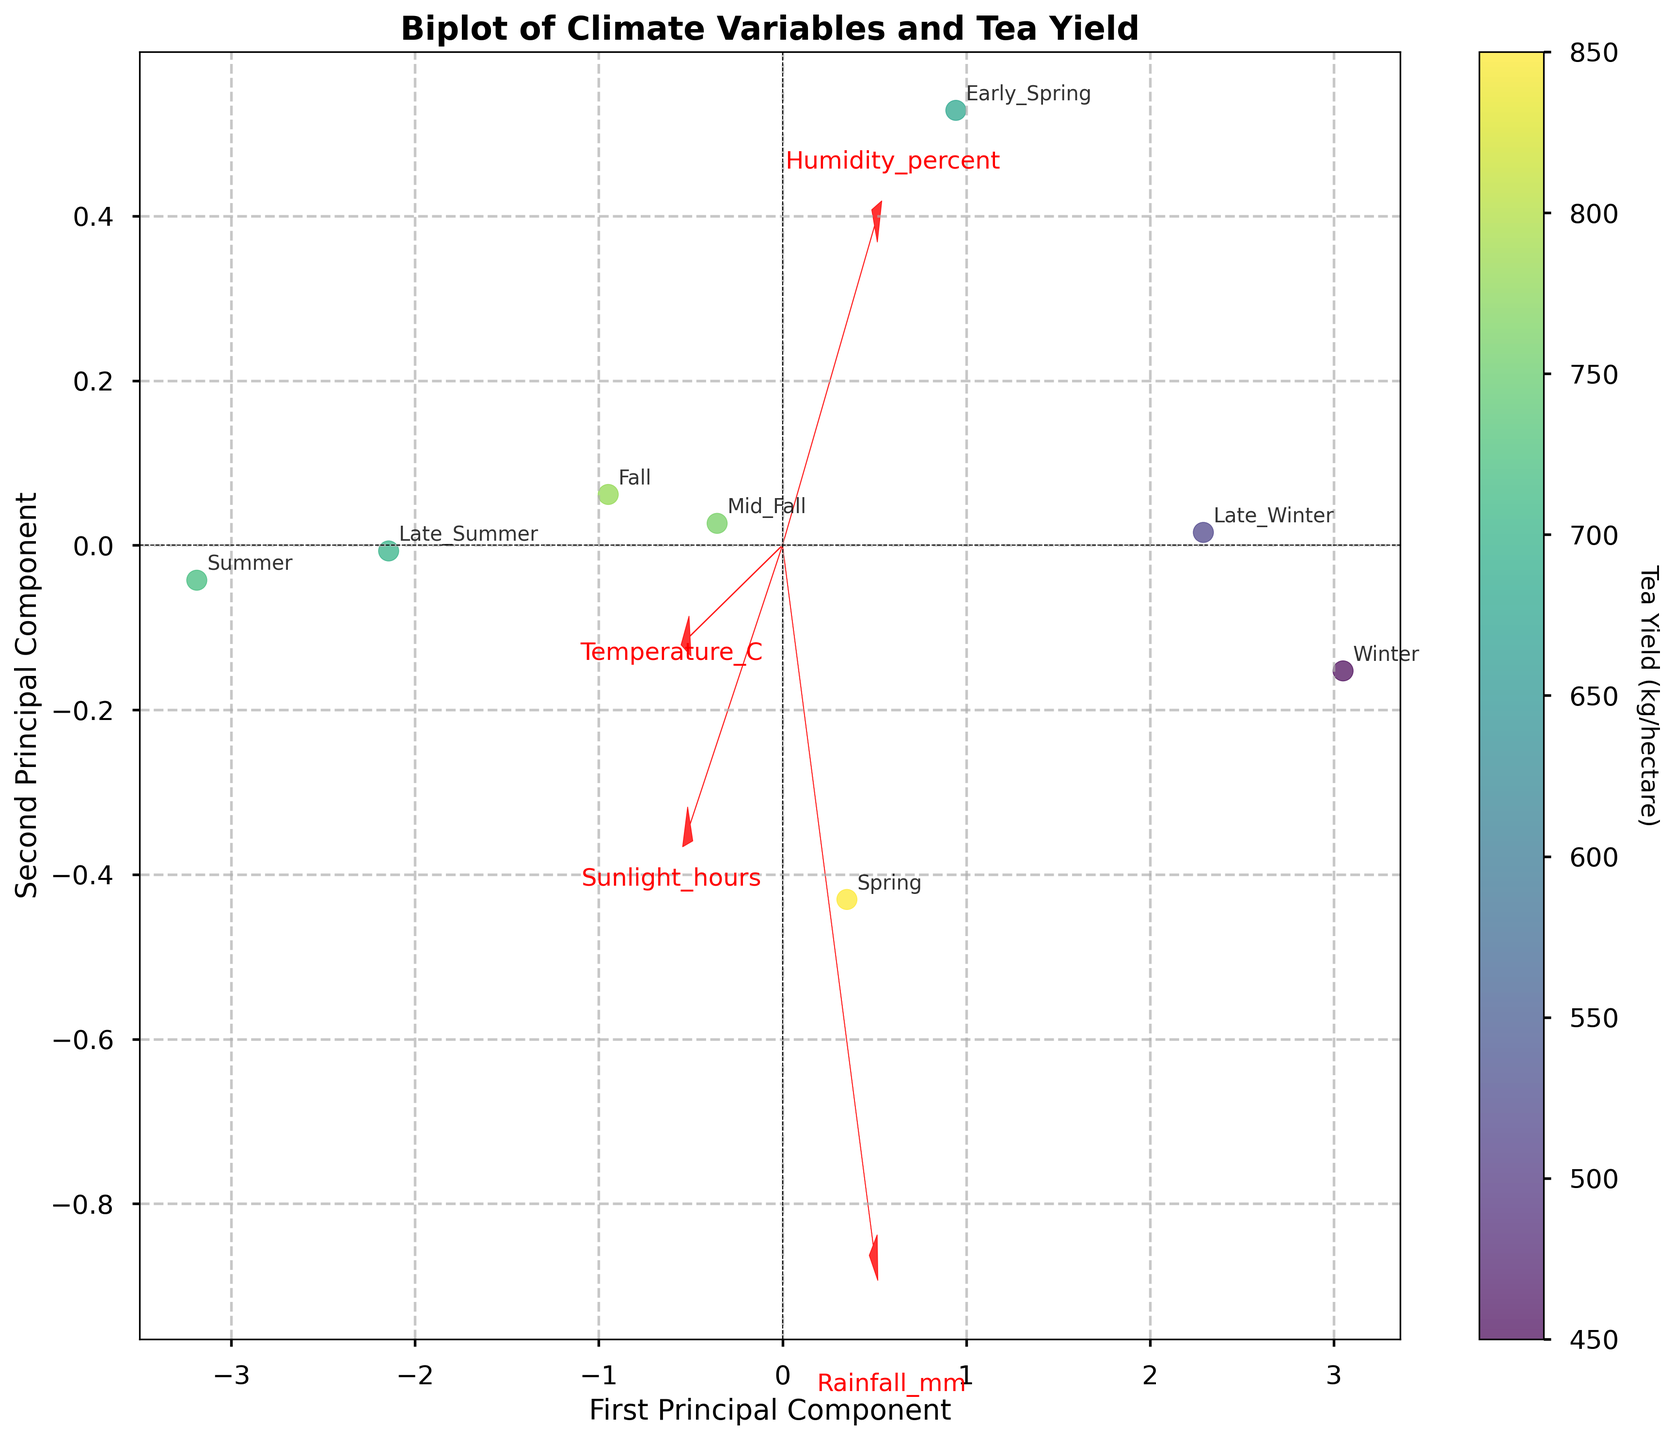What are the labels on the x-axis and y-axis? The labels are "First Principal Component" for the x-axis and "Second Principal Component" for the y-axis. These labels indicate the new coordinates after transforming the original variables using PCA.
Answer: First Principal Component, Second Principal Component Which season is closest to the origin? Look at the x and y coordinates of each labeled season to find which one is nearest to the (0, 0) point on the plot. "Fall" is closest to the origin.
Answer: Fall How does "Spring" relate to "Humidity_percent"? "Spring" is positioned in the direction where the "Humidity_percent" arrow points, indicating a positive relationship. This suggests that higher humidity is associated with Spring.
Answer: Positive relationship What is the color bar representing? The color bar on the right side of the plot is labeled "Tea Yield (kg/hectare)". It shows the tea yield per hectare, with different colors indicating different yields. This helps interpret the influence of climate variables on tea production visually.
Answer: Tea Yield (kg/hectare) Which season has the highest tea yield? By examining the colors of each season's point on the scatter plot, "Spring" is the darkest, indicating it has the highest yield.
Answer: Spring Which feature has the strongest influence on the first principal component? Examine the length of the arrows relative to the x-axis. "Rainfall_mm" has the longest arrow in the horizontal direction, indicating it has the strongest influence on the first principal component.
Answer: Rainfall_mm Compare the tea yield between "Late Winter" and "Summer". Look at the colors of the points for "Late Winter" and "Summer". "Late Winter" has a lighter color compared to "Summer", indicating a lower tea yield.
Answer: Summer > Late Winter What can be inferred about "Temperature_C" and tea yield in "Summer"? The "Temperature_C" arrow points towards "Summer", suggesting a positive relationship. The color for "Summer" is relatively dark, indicating a good tea yield. Thus, higher temperatures are positively associated with tea yield in summer.
Answer: Positive relationship, good yield Which feature vector most aligns with "Winter"? By viewing the direction of the "Winter" point relative to the feature vectors, "Humidity_percent" aligns most closely, implying "Winter" has a strong association with high humidity.
Answer: Humidity_percent What is the overall trend of the seasons in terms of "Sunlight_hours"? Observe the directions of the points and "Sunlight_hours" arrow. Seasons like "Summer" and "Late Summer" are aligned with the direction of "Sunlight_hours", indicating a trend of increased sunlight in these seasons.
Answer: Positive trend in "Summer" and "Late Summer" 